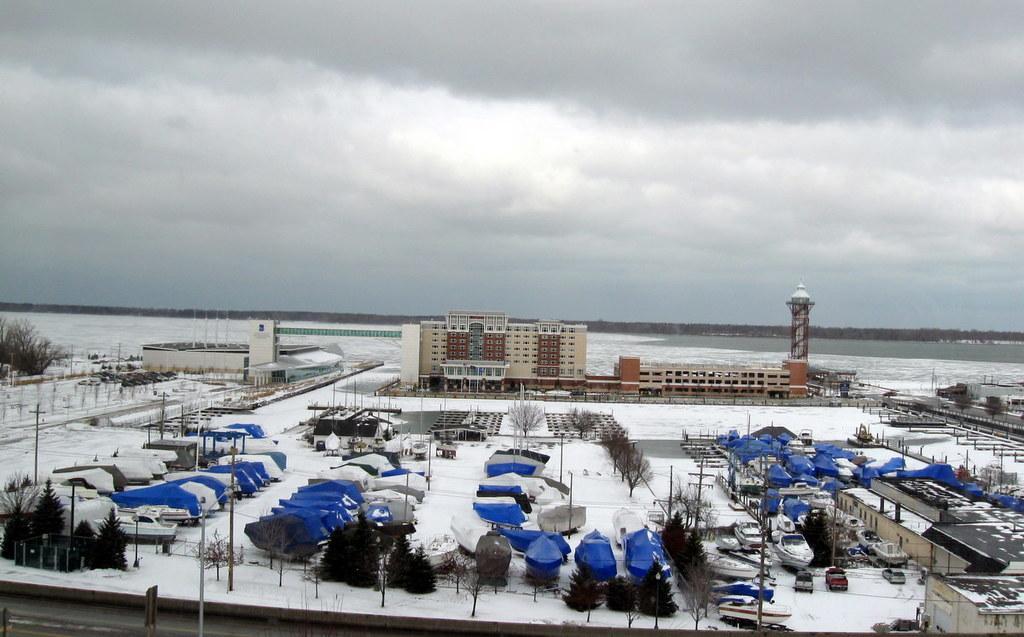Can you describe this image briefly? At the bottom of this image, there are trees, boats, vehicles, buildings and snow surface on the ground. In the background, there are trees and there are clouds in the sky. 